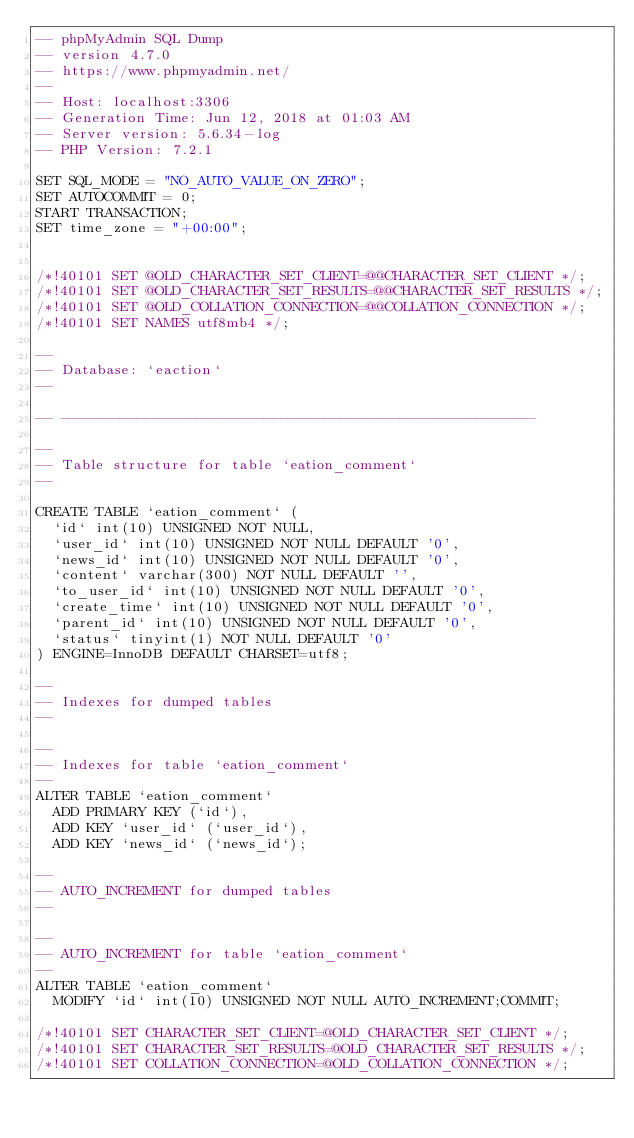<code> <loc_0><loc_0><loc_500><loc_500><_SQL_>-- phpMyAdmin SQL Dump
-- version 4.7.0
-- https://www.phpmyadmin.net/
--
-- Host: localhost:3306
-- Generation Time: Jun 12, 2018 at 01:03 AM
-- Server version: 5.6.34-log
-- PHP Version: 7.2.1

SET SQL_MODE = "NO_AUTO_VALUE_ON_ZERO";
SET AUTOCOMMIT = 0;
START TRANSACTION;
SET time_zone = "+00:00";


/*!40101 SET @OLD_CHARACTER_SET_CLIENT=@@CHARACTER_SET_CLIENT */;
/*!40101 SET @OLD_CHARACTER_SET_RESULTS=@@CHARACTER_SET_RESULTS */;
/*!40101 SET @OLD_COLLATION_CONNECTION=@@COLLATION_CONNECTION */;
/*!40101 SET NAMES utf8mb4 */;

--
-- Database: `eaction`
--

-- --------------------------------------------------------

--
-- Table structure for table `eation_comment`
--

CREATE TABLE `eation_comment` (
  `id` int(10) UNSIGNED NOT NULL,
  `user_id` int(10) UNSIGNED NOT NULL DEFAULT '0',
  `news_id` int(10) UNSIGNED NOT NULL DEFAULT '0',
  `content` varchar(300) NOT NULL DEFAULT '',
  `to_user_id` int(10) UNSIGNED NOT NULL DEFAULT '0',
  `create_time` int(10) UNSIGNED NOT NULL DEFAULT '0',
  `parent_id` int(10) UNSIGNED NOT NULL DEFAULT '0',
  `status` tinyint(1) NOT NULL DEFAULT '0'
) ENGINE=InnoDB DEFAULT CHARSET=utf8;

--
-- Indexes for dumped tables
--

--
-- Indexes for table `eation_comment`
--
ALTER TABLE `eation_comment`
  ADD PRIMARY KEY (`id`),
  ADD KEY `user_id` (`user_id`),
  ADD KEY `news_id` (`news_id`);

--
-- AUTO_INCREMENT for dumped tables
--

--
-- AUTO_INCREMENT for table `eation_comment`
--
ALTER TABLE `eation_comment`
  MODIFY `id` int(10) UNSIGNED NOT NULL AUTO_INCREMENT;COMMIT;

/*!40101 SET CHARACTER_SET_CLIENT=@OLD_CHARACTER_SET_CLIENT */;
/*!40101 SET CHARACTER_SET_RESULTS=@OLD_CHARACTER_SET_RESULTS */;
/*!40101 SET COLLATION_CONNECTION=@OLD_COLLATION_CONNECTION */;
</code> 